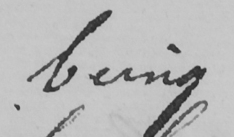Can you tell me what this handwritten text says? being 